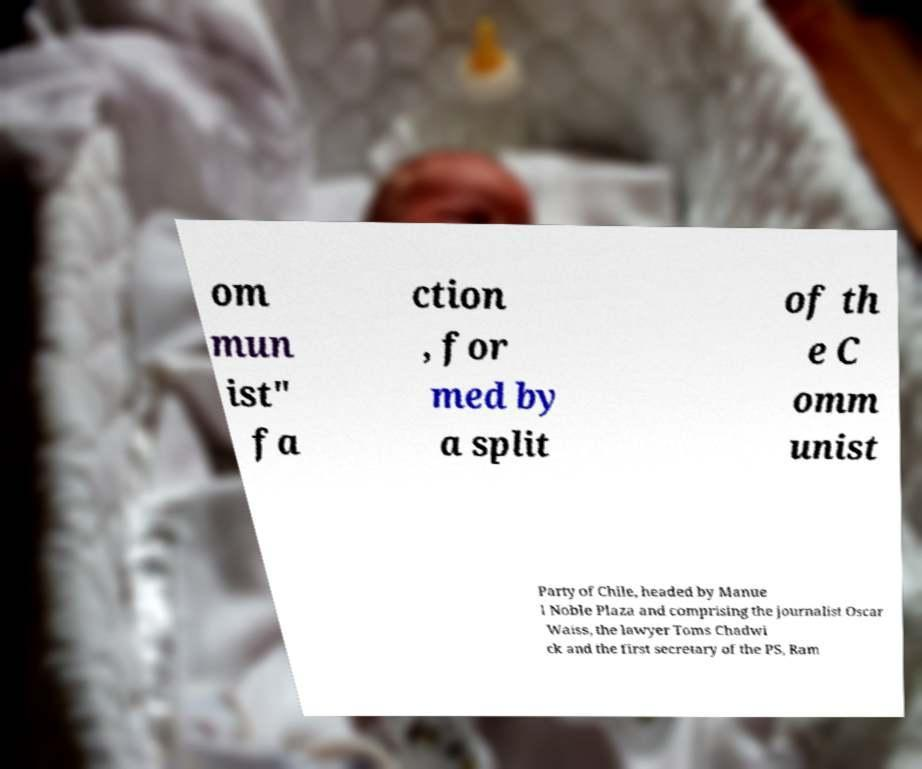Can you accurately transcribe the text from the provided image for me? om mun ist" fa ction , for med by a split of th e C omm unist Party of Chile, headed by Manue l Noble Plaza and comprising the journalist Oscar Waiss, the lawyer Toms Chadwi ck and the first secretary of the PS, Ram 